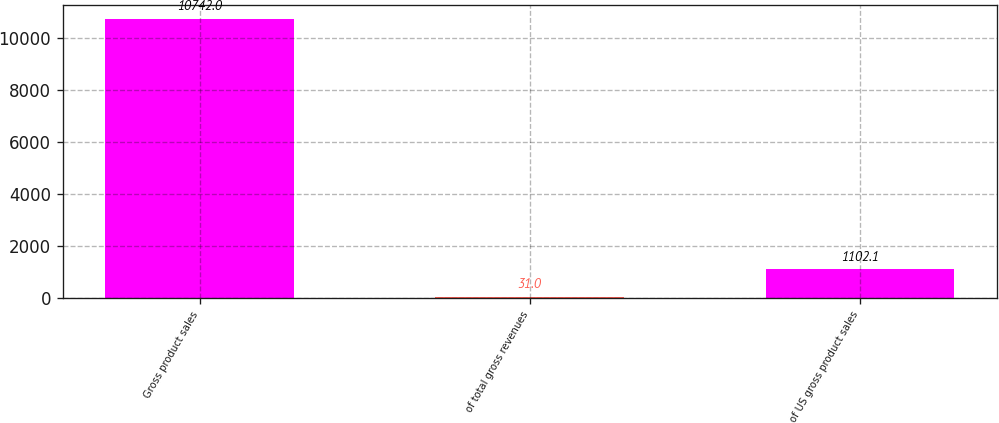<chart> <loc_0><loc_0><loc_500><loc_500><bar_chart><fcel>Gross product sales<fcel>of total gross revenues<fcel>of US gross product sales<nl><fcel>10742<fcel>31<fcel>1102.1<nl></chart> 